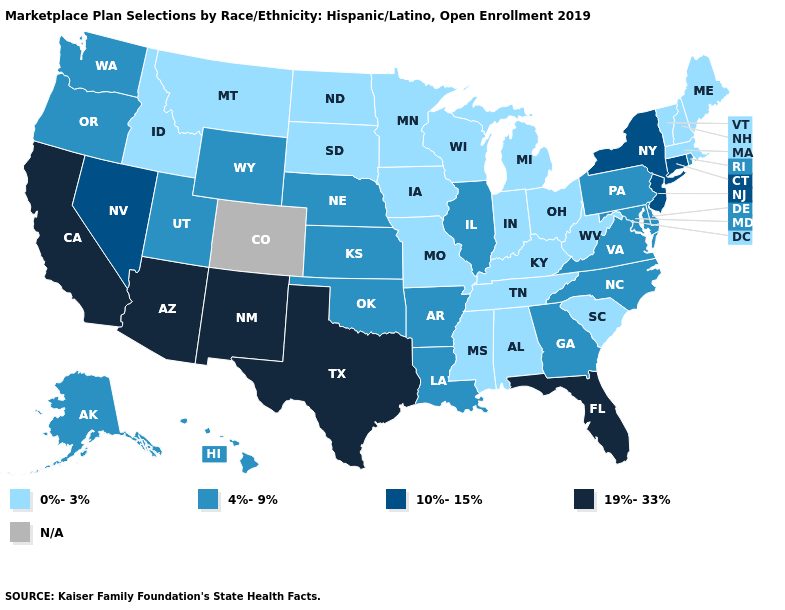What is the value of West Virginia?
Give a very brief answer. 0%-3%. What is the value of Connecticut?
Answer briefly. 10%-15%. Name the states that have a value in the range 4%-9%?
Short answer required. Alaska, Arkansas, Delaware, Georgia, Hawaii, Illinois, Kansas, Louisiana, Maryland, Nebraska, North Carolina, Oklahoma, Oregon, Pennsylvania, Rhode Island, Utah, Virginia, Washington, Wyoming. What is the value of New Mexico?
Quick response, please. 19%-33%. Name the states that have a value in the range 19%-33%?
Write a very short answer. Arizona, California, Florida, New Mexico, Texas. What is the lowest value in states that border Nebraska?
Keep it brief. 0%-3%. Does the map have missing data?
Be succinct. Yes. What is the highest value in the MidWest ?
Short answer required. 4%-9%. Does the first symbol in the legend represent the smallest category?
Keep it brief. Yes. Among the states that border New Mexico , does Utah have the highest value?
Quick response, please. No. Which states hav the highest value in the West?
Quick response, please. Arizona, California, New Mexico. What is the value of Idaho?
Short answer required. 0%-3%. What is the lowest value in the USA?
Short answer required. 0%-3%. What is the value of Wisconsin?
Short answer required. 0%-3%. What is the highest value in states that border Iowa?
Quick response, please. 4%-9%. 